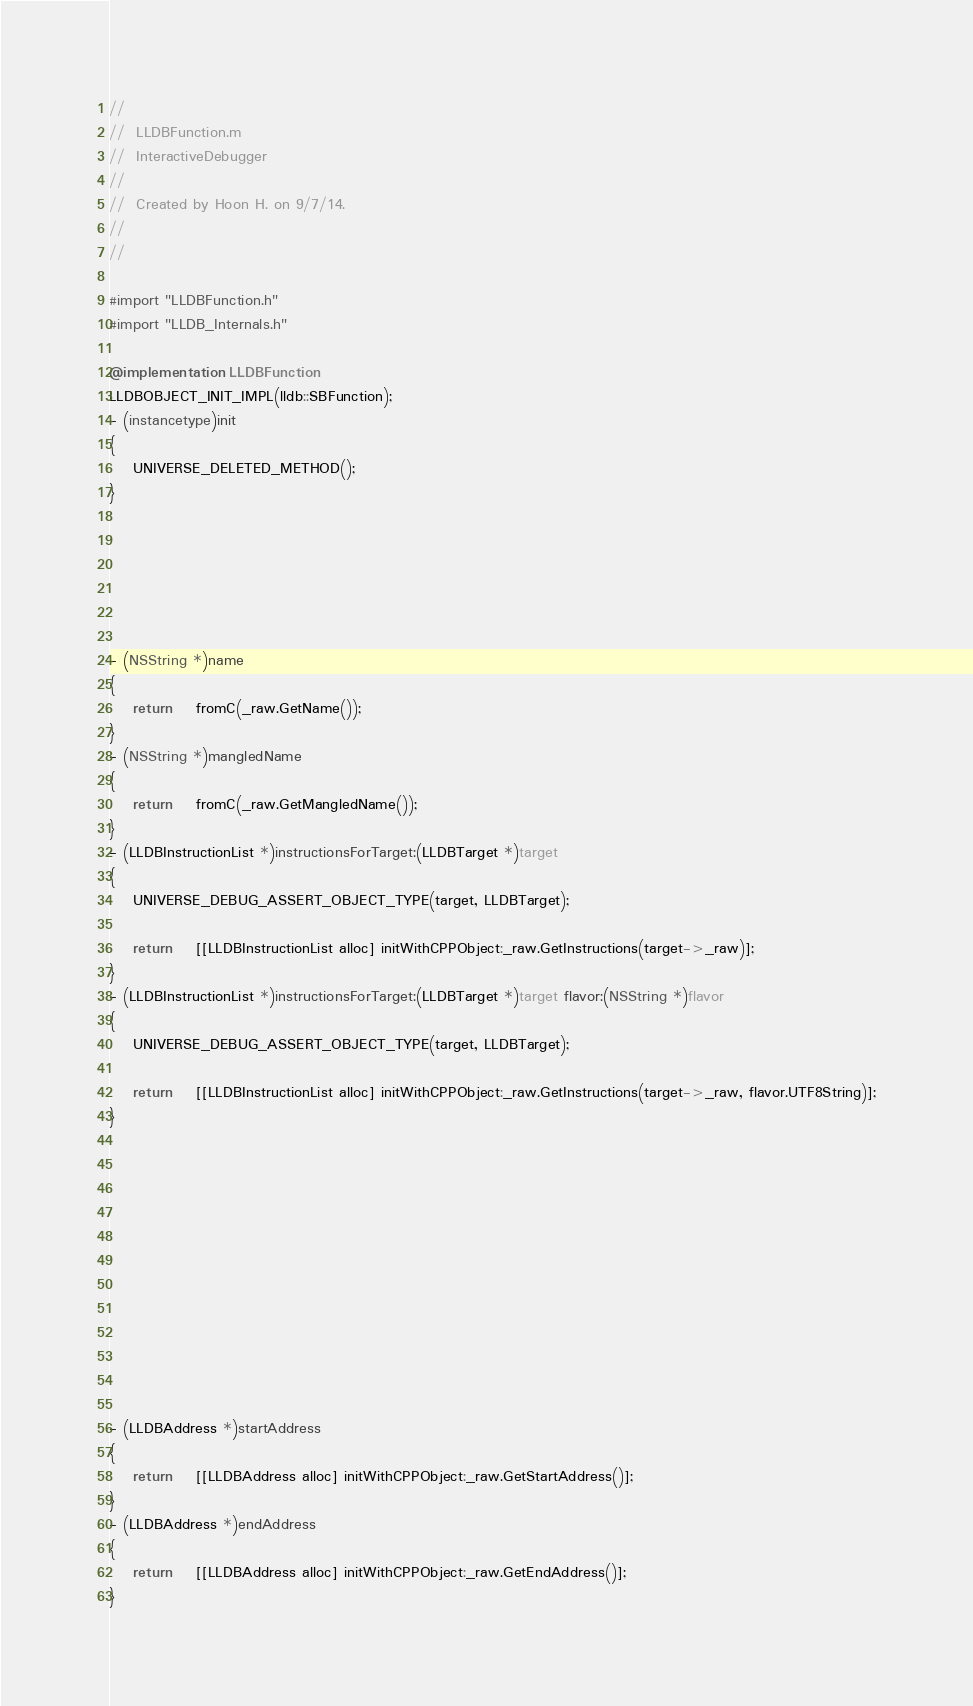<code> <loc_0><loc_0><loc_500><loc_500><_ObjectiveC_>//
//  LLDBFunction.m
//  InteractiveDebugger
//
//  Created by Hoon H. on 9/7/14.
//
//

#import "LLDBFunction.h"
#import "LLDB_Internals.h"

@implementation LLDBFunction
LLDBOBJECT_INIT_IMPL(lldb::SBFunction);
- (instancetype)init
{
	UNIVERSE_DELETED_METHOD();
}






- (NSString *)name
{
	return	fromC(_raw.GetName());
}
- (NSString *)mangledName
{
	return	fromC(_raw.GetMangledName());
}
- (LLDBInstructionList *)instructionsForTarget:(LLDBTarget *)target
{
	UNIVERSE_DEBUG_ASSERT_OBJECT_TYPE(target, LLDBTarget);
	
	return	[[LLDBInstructionList alloc] initWithCPPObject:_raw.GetInstructions(target->_raw)];
}
- (LLDBInstructionList *)instructionsForTarget:(LLDBTarget *)target flavor:(NSString *)flavor
{
	UNIVERSE_DEBUG_ASSERT_OBJECT_TYPE(target, LLDBTarget);
	
	return	[[LLDBInstructionList alloc] initWithCPPObject:_raw.GetInstructions(target->_raw, flavor.UTF8String)];
}












- (LLDBAddress *)startAddress
{
	return	[[LLDBAddress alloc] initWithCPPObject:_raw.GetStartAddress()];
}
- (LLDBAddress *)endAddress
{
	return	[[LLDBAddress alloc] initWithCPPObject:_raw.GetEndAddress()];
}</code> 